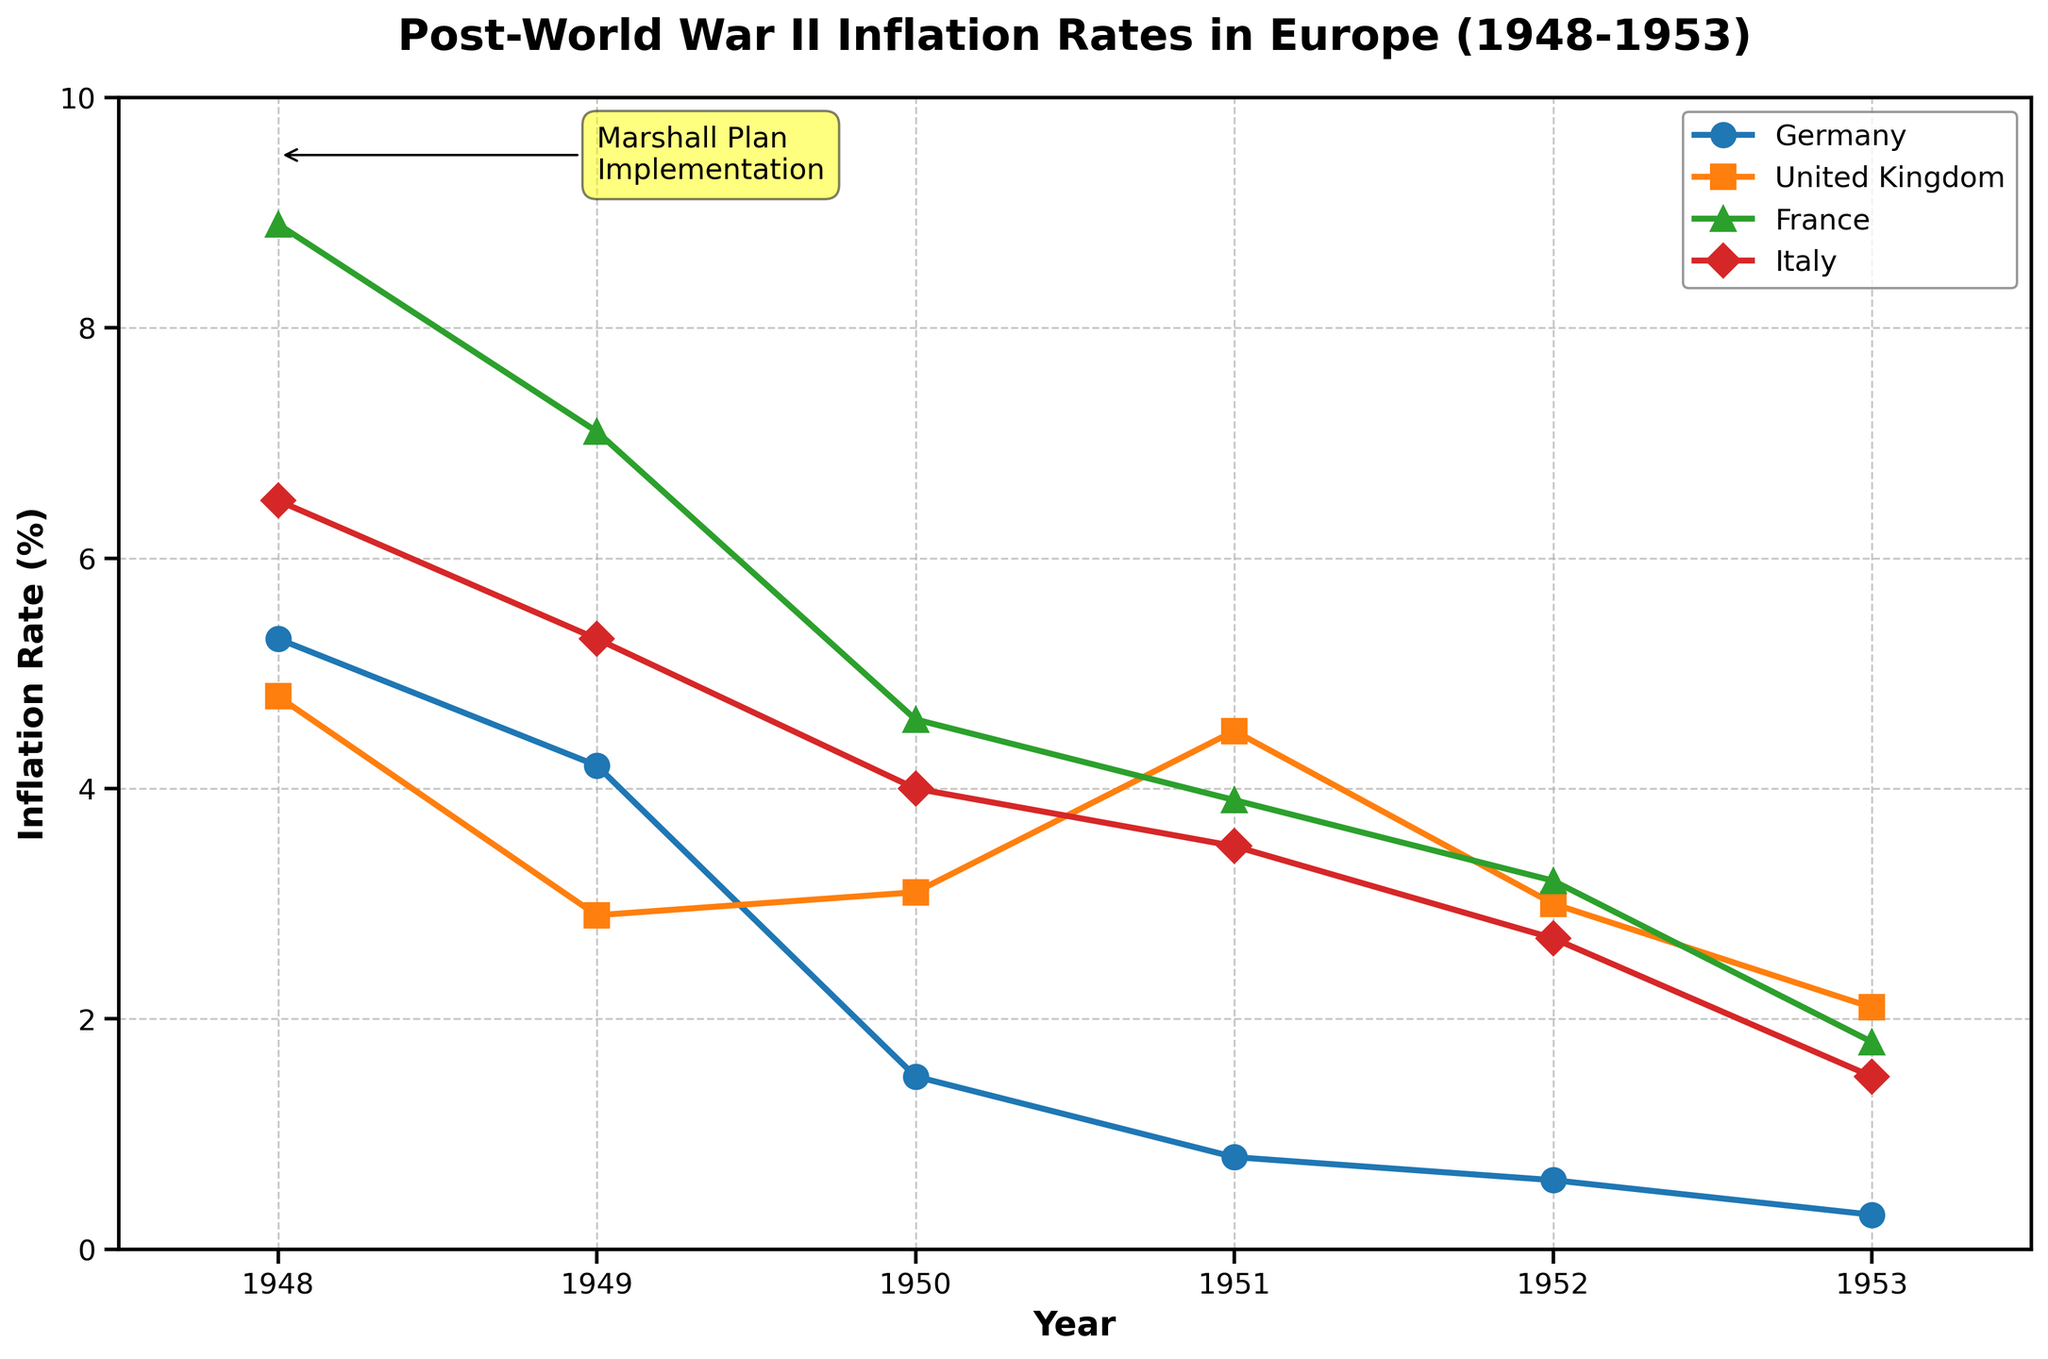What is the title of the plot? The title is located at the top center of the plot, which should clearly indicate what the plot is about. It reads "Post-World War II Inflation Rates in Europe (1948-1953)."
Answer: Post-World War II Inflation Rates in Europe (1948-1953) What are the axes labels? The axes labels are found along the horizontal and vertical lines that frame the data points. The x-axis is labeled "Year," and the y-axis is labeled "Inflation Rate (%)."
Answer: Year, Inflation Rate (%) Which country has the highest inflation rate in 1948? To find this, locate the data points for the year 1948 on the x-axis and identify which country has the highest value on the y-axis. France has the highest inflation rate at approximately 8.9%.
Answer: France How did the inflation rate in Germany change from 1948 to 1953? Look at the data points for Germany from 1948 to 1953. In 1948, it was 5.3% and gradually decreased each year down to 0.3% in 1953.
Answer: It decreased from 5.3% to 0.3% Compare the inflation rates of Italy and the United Kingdom in 1950. Which country had a higher rate? Locate the year 1950 on the x-axis and compare the inflation rates for Italy (4.0%) and the United Kingdom (3.1%). Italy had a higher rate.
Answer: Italy What is the average inflation rate of France from 1948 to 1953? First, locate the inflation rates for France over the given years: 8.9%, 7.1%, 4.6%, 3.9%, 3.2%, and 1.8%. Then, compute the average by summing these values and dividing by the number of years:
(8.9 + 7.1 + 4.6 + 3.9 + 3.2 + 1.8) / 6 = 29.5 / 6 ≈ 4.92
Answer: 4.92% Which country had the lowest inflation rate in 1951? For the year 1951, compare the inflation rates of all countries. Germany had the lowest at 0.8%.
Answer: Germany By how much did the UK's inflation rate change from 1949 to 1952? Locate the UK's inflation rates for 1949 (2.9%) and 1952 (3.0%). The change is calculated as 3.0% - 2.9% = 0.1%.
Answer: 0.1% What trend is observed in the inflation rates for all countries from 1948 to 1953? Analyze the plot lines for all countries. Generally, a downward trend is seen in the inflation rates from 1948 to 1953, indicating a decrease over these years.
Answer: Downward trend Which year shows the most significant overall decrease in inflation rates for all countries compared to the previous year? Compare the inflation rates year-over-year for all countries. The most significant decrease appears from 1949 to 1950, with Germany dropping from 4.2% to 1.5%, France from 7.1% to 4.6%, and United Kingdom increasing slightly from 2.9% to 3.1%.
Answer: 1950 